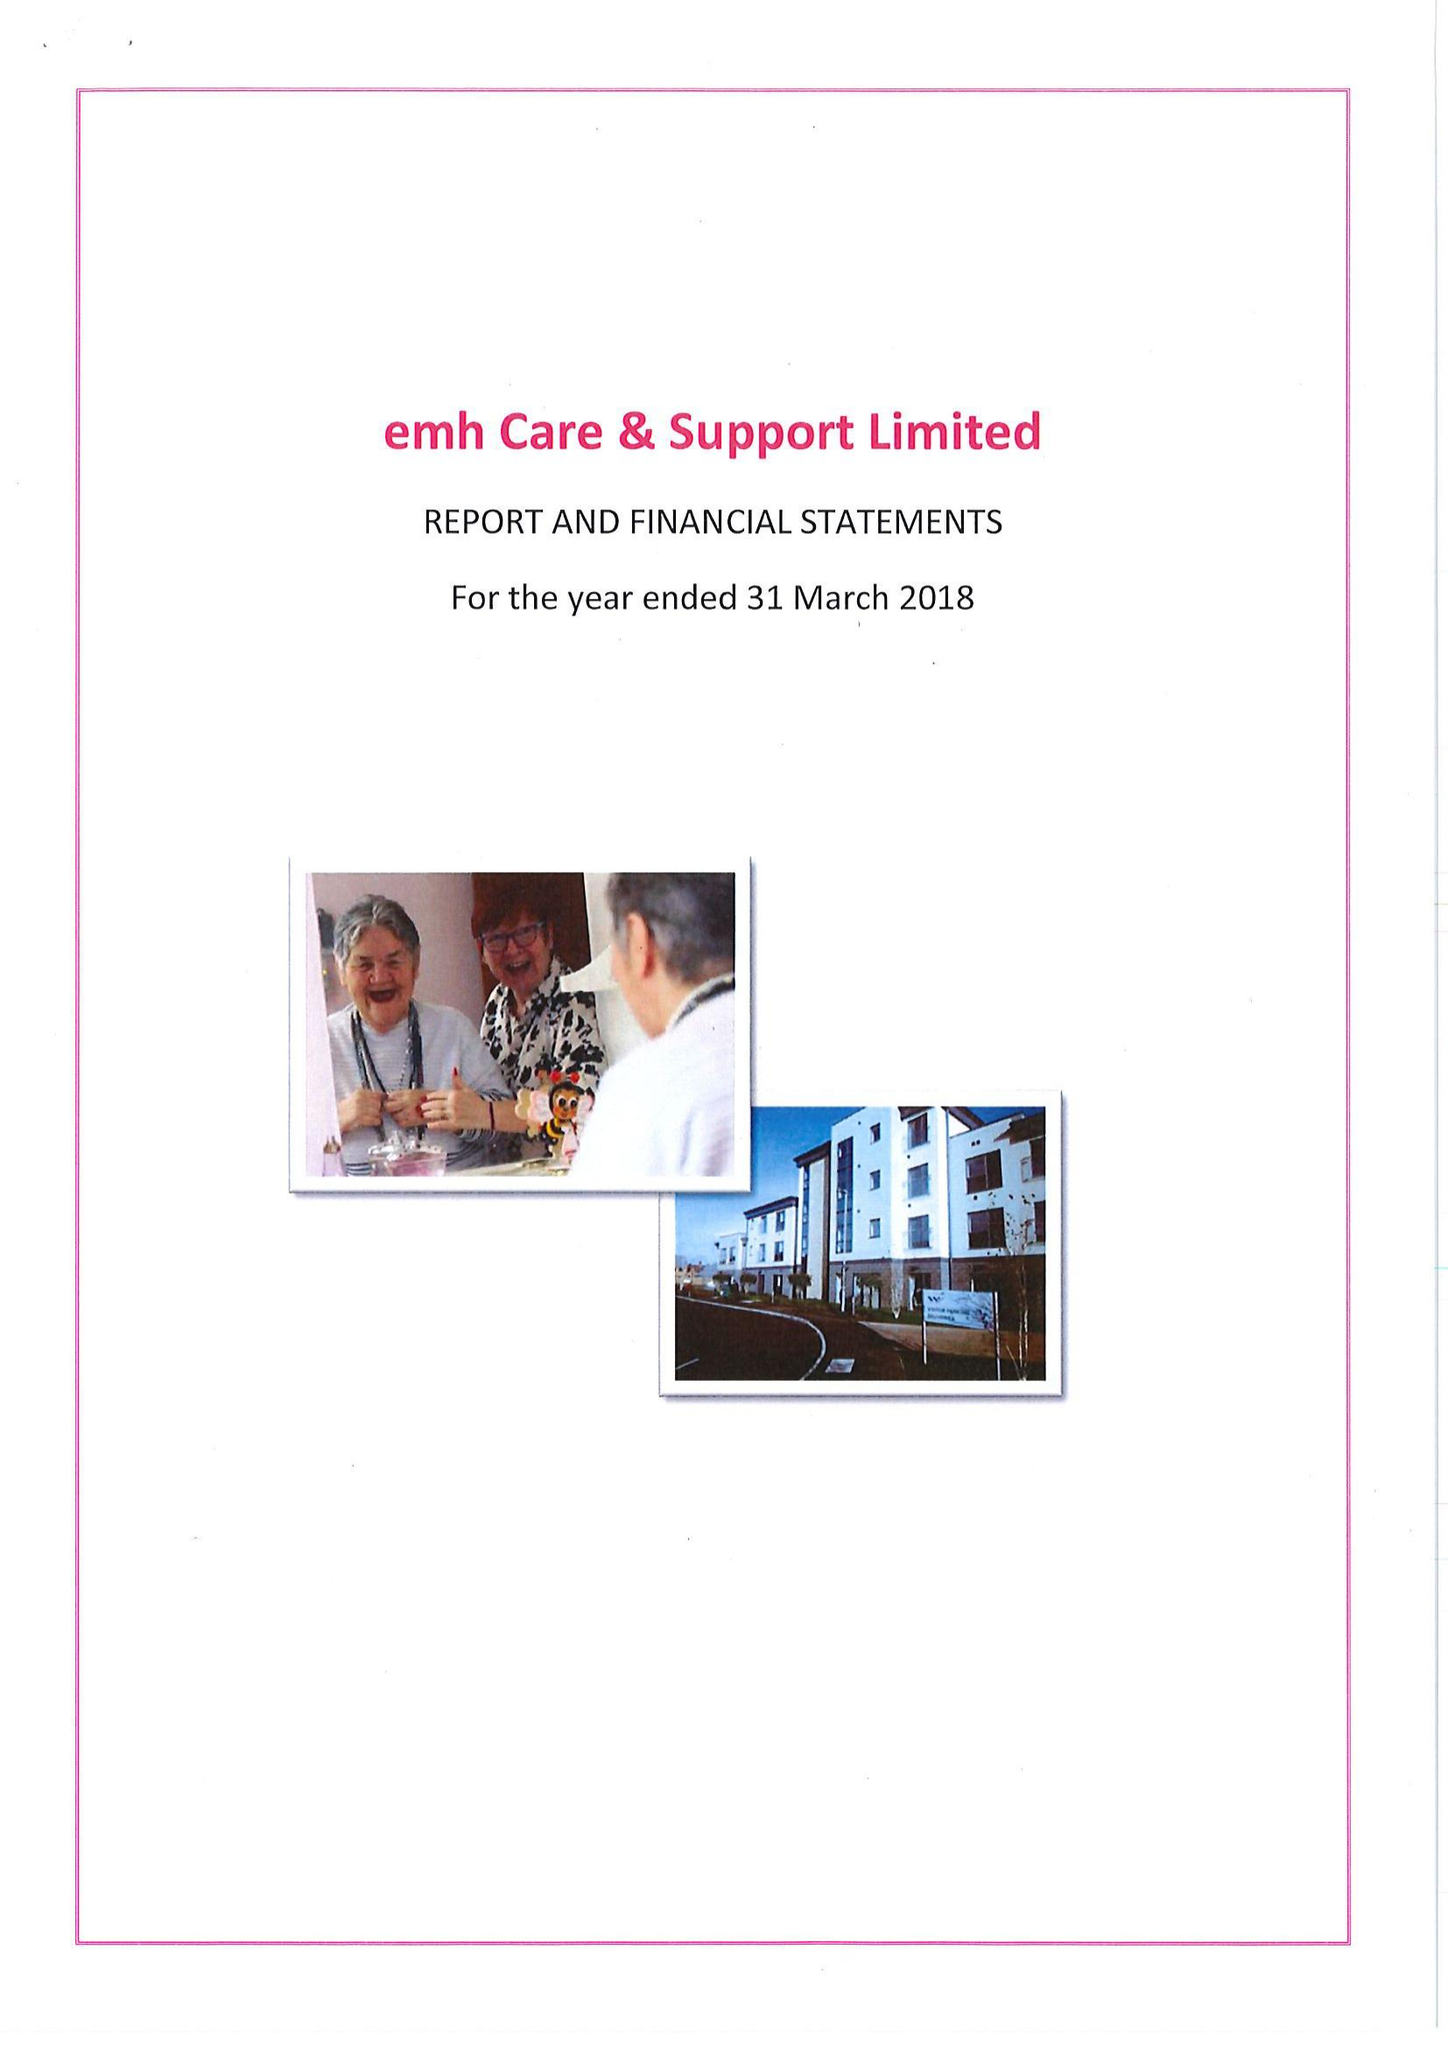What is the value for the charity_number?
Answer the question using a single word or phrase. 1001704 